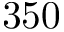<formula> <loc_0><loc_0><loc_500><loc_500>3 5 0</formula> 